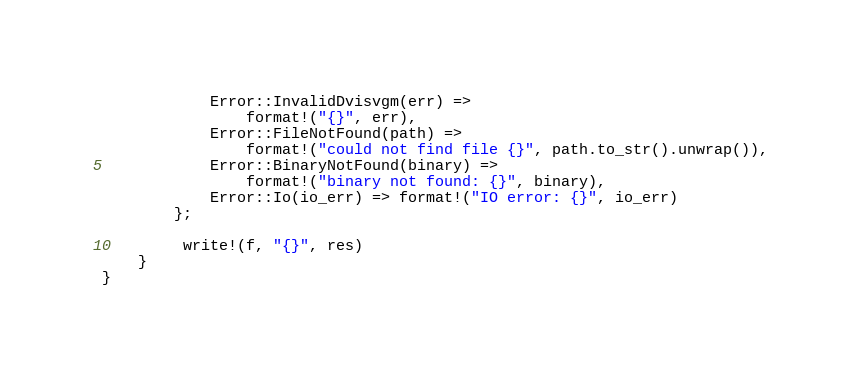Convert code to text. <code><loc_0><loc_0><loc_500><loc_500><_Rust_>            Error::InvalidDvisvgm(err) => 
                format!("{}", err),
            Error::FileNotFound(path) =>
                format!("could not find file {}", path.to_str().unwrap()),
            Error::BinaryNotFound(binary) => 
                format!("binary not found: {}", binary),
            Error::Io(io_err) => format!("IO error: {}", io_err)
        };

         write!(f, "{}", res)
    }
}
</code> 